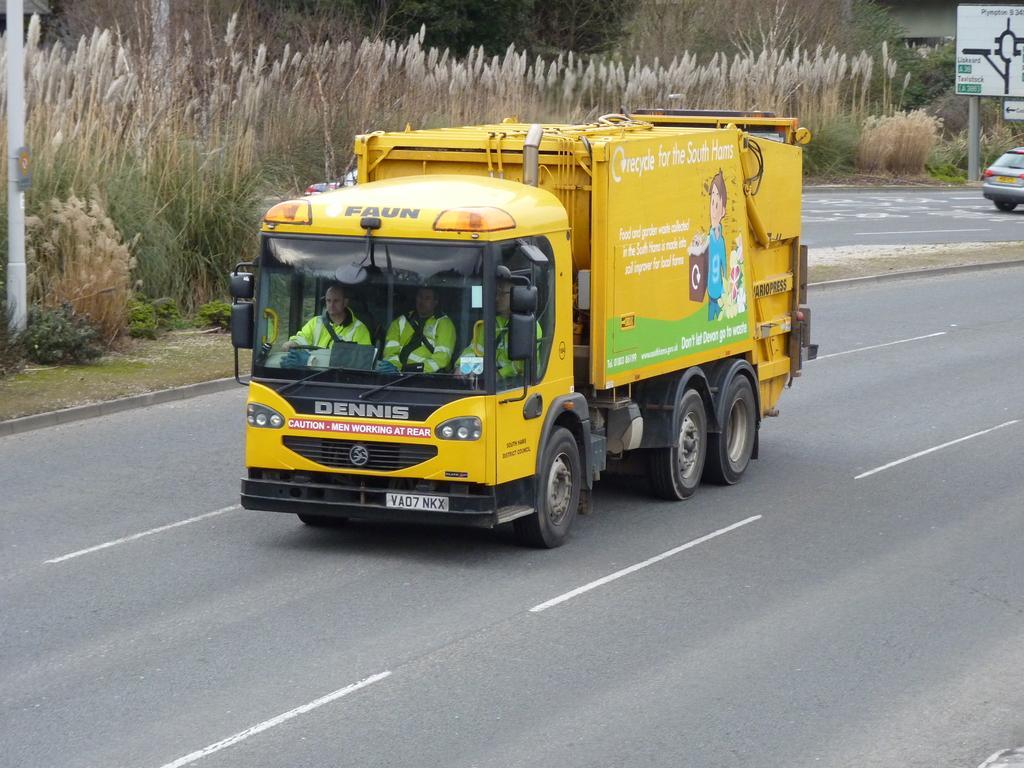How would you summarize this image in a sentence or two? In the center of the image there is a truck on the road. In the background of the image there is grass and trees. There is a sign board. 